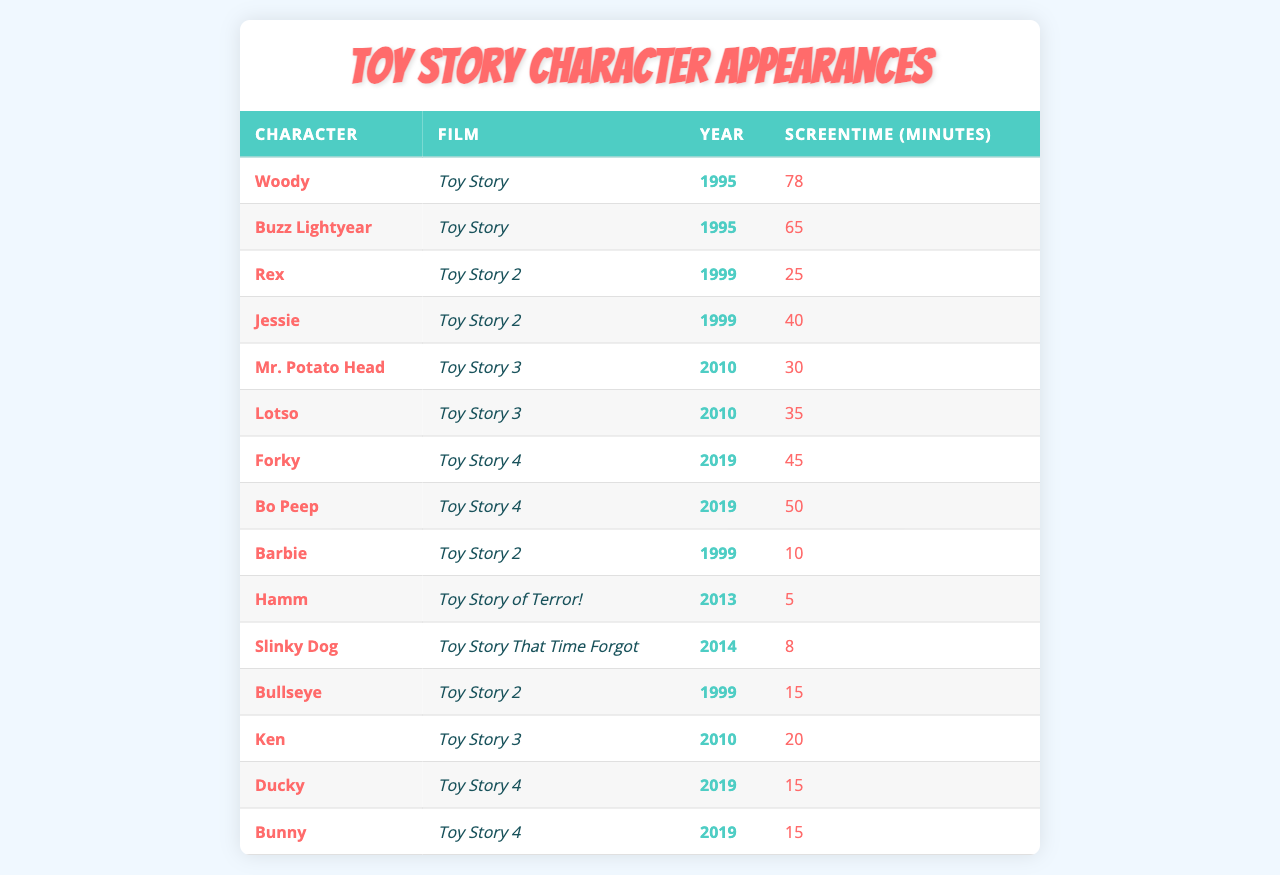What film features the most characters? In the table, we can see "Toy Story 2" has four characters: Rex, Jessie, Barbie, and Bullseye. This is more than any other film.
Answer: Toy Story 2 How many minutes does Woody appear on screen? Woody's total screen time is specifically listed in the table as 78 minutes in the film "Toy Story."
Answer: 78 minutes Which character appeared in the first Toy Story movie? According to the table, both Woody and Buzz Lightyear appeared in the first Toy Story movie released in 1995.
Answer: Woody and Buzz Lightyear What is the total screen time for characters in Toy Story 3? The screen times in Toy Story 3 are 30 minutes (Mr. Potato Head), 35 minutes (Lotso), and 20 minutes (Ken). Adding these gives 30 + 35 + 20 = 85 minutes.
Answer: 85 minutes Which character has the least screen time, and how long is it? The table shows Hamm appeared for 5 minutes in "Toy Story of Terror!" This is the least compared to all other characters listed.
Answer: Hamm, 5 minutes Is there any character that appeared in every film except Toy Story of Terror!? By reviewing the table, Woody and Buzz Lightyear are consistently present in all the main Toy Story films but do not appear in "Toy Story of Terror!". So, they do not appear in that short.
Answer: Yes Which film had the longest average character screentime? To find this, calculate the average screentime for each film: "Toy Story" (78 + 65) / 2 = 71.5, "Toy Story 2" (25 + 40 + 10 + 15) / 4 = 22.5, "Toy Story 3" (30 + 35 + 20) / 3 = 28.33, "Toy Story 4" (45 + 50 + 15 + 15) / 4 = 31.25. "Toy Story" has the highest average at 71.5 minutes.
Answer: Toy Story How many characters appear in Toy Story 4? The table lists four characters in "Toy Story 4": Forky, Bo Peep, Ducky, and Bunny.
Answer: 4 characters Which character has the highest screen time in Toy Story 4? In "Toy Story 4," Bo Peep has the highest screen time at 50 minutes, surpassing Forky (45 minutes) and the others.
Answer: Bo Peep, 50 minutes Does the character Ken appear in more than one Toy Story film? The table lists Ken only under "Toy Story 3," indicating that he did not appear in multiple films.
Answer: No 